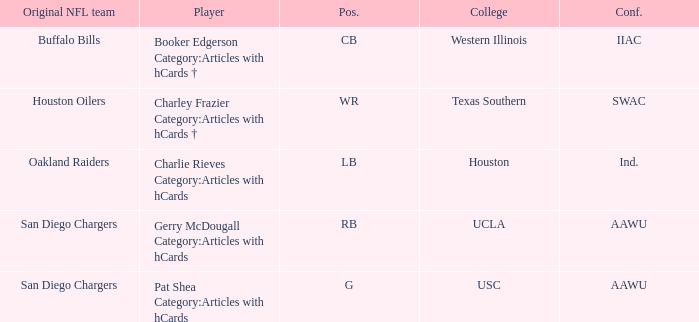What player's original team are the Buffalo Bills? Booker Edgerson Category:Articles with hCards †. 